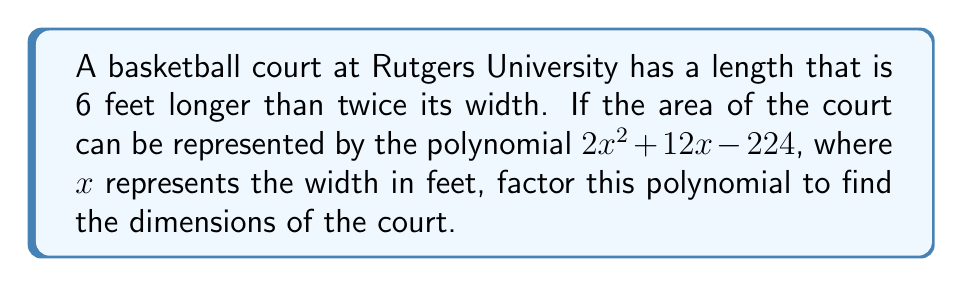Provide a solution to this math problem. Let's approach this step-by-step:

1) We're given that the area of the court is represented by $2x^2 + 12x - 224$, where $x$ is the width.

2) We're also told that the length is 6 feet longer than twice the width. So if $x$ is the width, the length is $2x + 6$.

3) The area of a rectangle is length times width. So we can set up the equation:

   $x(2x + 6) = 2x^2 + 12x - 224$

4) Expanding the left side:

   $2x^2 + 6x = 2x^2 + 12x - 224$

5) These should be equivalent, so we can subtract $2x^2$ and $6x$ from both sides:

   $0 = 6x - 224$

6) Adding 224 to both sides:

   $224 = 6x$

7) Dividing by 6:

   $\frac{224}{6} = x$
   $37.\overline{3} = x$

8) So the width is $37\frac{1}{3}$ feet. The length would be $2(37\frac{1}{3}) + 6 = 80\frac{2}{3}$ feet.

9) Now, let's factor the original polynomial $2x^2 + 12x - 224$:

   First, multiply everything by 2 to make the leading coefficient 1:
   $4x^2 + 24x - 448$

   The factors of -448 that add up to 24 are 56 and -32.

   So we can rewrite this as:
   $4x^2 + 56x - 32x - 448$
   $4x(x + 14) - 32(x + 14)$
   $(4x - 32)(x + 14)$

   Dividing the first factor by 2 to get back to our original polynomial:
   $(2x - 16)(x + 14)$

10) Therefore, the factored form of $2x^2 + 12x - 224$ is $2(x - 8)(x + 14)$
Answer: $2(x - 8)(x + 14)$ 